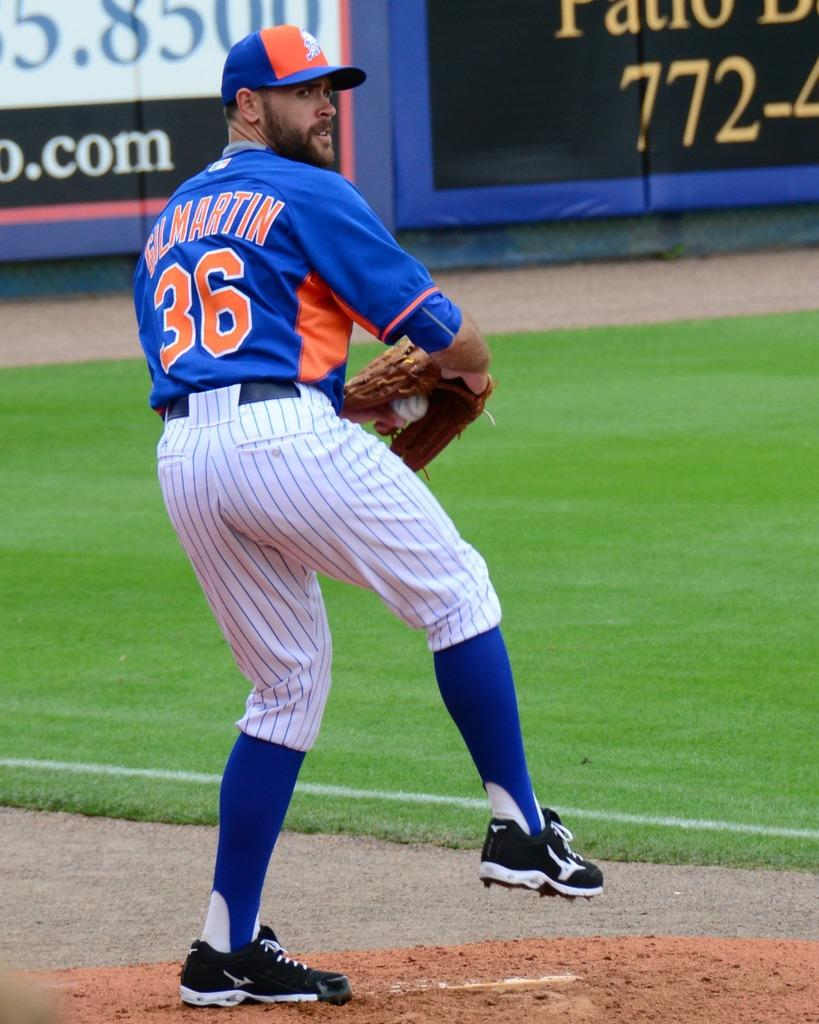<image>
Provide a brief description of the given image. The pitcher who wears number 36 throws a pitch to a batter. 